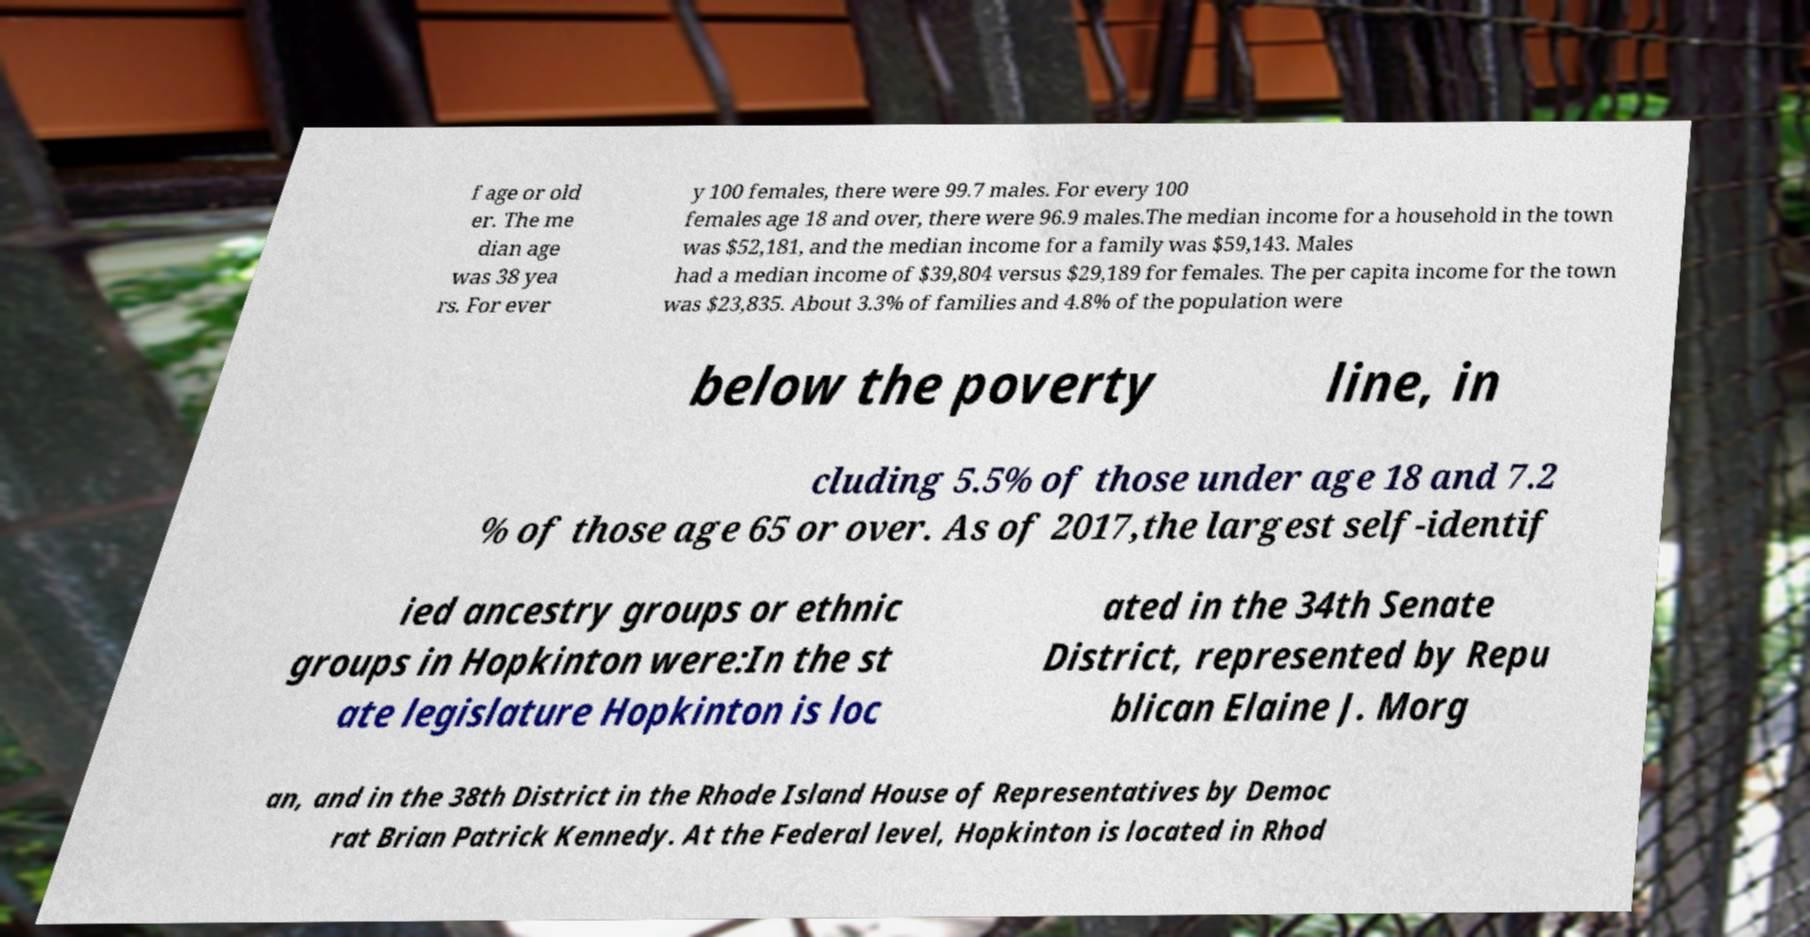Please identify and transcribe the text found in this image. f age or old er. The me dian age was 38 yea rs. For ever y 100 females, there were 99.7 males. For every 100 females age 18 and over, there were 96.9 males.The median income for a household in the town was $52,181, and the median income for a family was $59,143. Males had a median income of $39,804 versus $29,189 for females. The per capita income for the town was $23,835. About 3.3% of families and 4.8% of the population were below the poverty line, in cluding 5.5% of those under age 18 and 7.2 % of those age 65 or over. As of 2017,the largest self-identif ied ancestry groups or ethnic groups in Hopkinton were:In the st ate legislature Hopkinton is loc ated in the 34th Senate District, represented by Repu blican Elaine J. Morg an, and in the 38th District in the Rhode Island House of Representatives by Democ rat Brian Patrick Kennedy. At the Federal level, Hopkinton is located in Rhod 